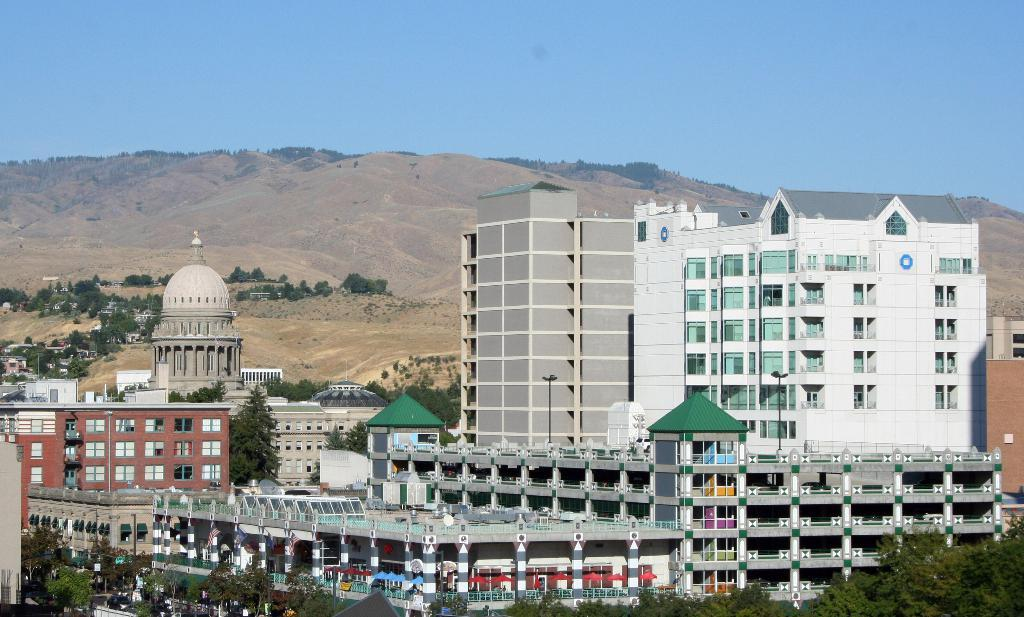What type of natural elements can be seen at the bottom of the image? There are trees at the bottom of the image. What type of man-made structures are present at the bottom of the image? There are buildings at the bottom of the image. What geographical feature is visible behind the buildings? A hill is visible behind the buildings. What is visible at the top of the image? The sky is visible at the top of the image. How does the tail of the animal affect the value of the property in the image? There is no animal or property present in the image, so it is not possible to determine the effect of a tail on the value of a property. 